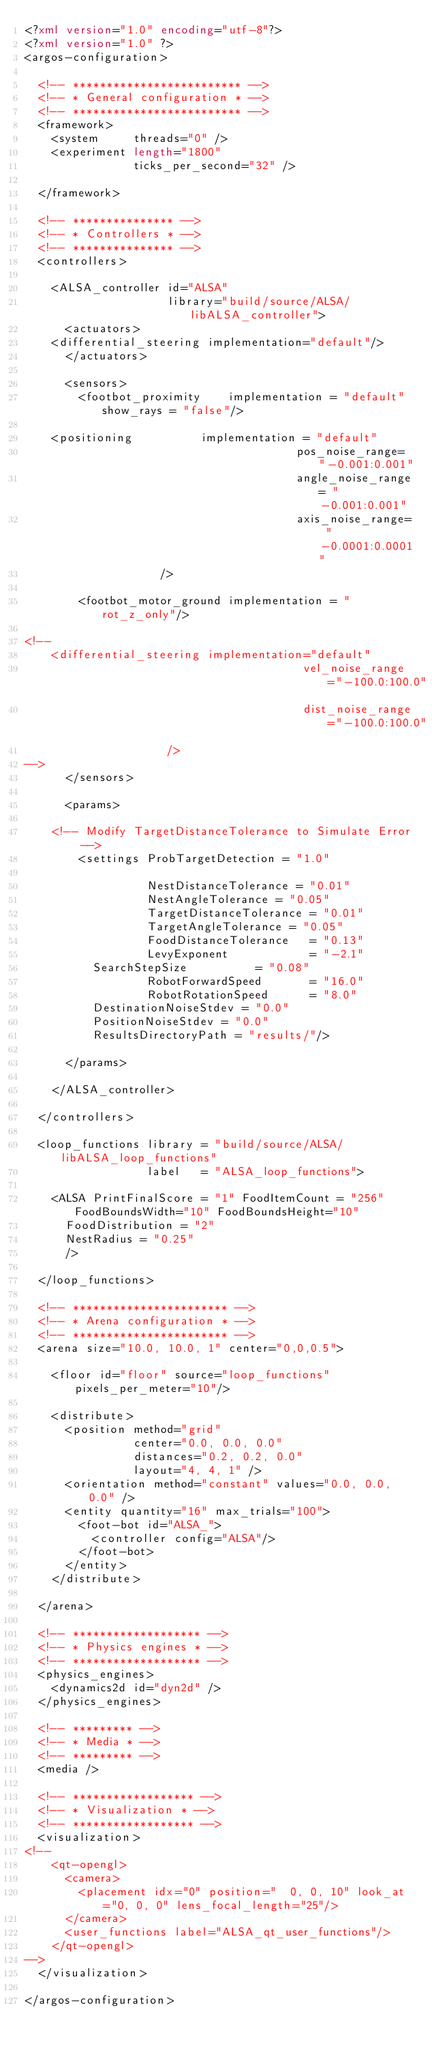Convert code to text. <code><loc_0><loc_0><loc_500><loc_500><_XML_><?xml version="1.0" encoding="utf-8"?>
<?xml version="1.0" ?>
<argos-configuration>

  <!-- ************************* -->
  <!-- * General configuration * -->
  <!-- ************************* -->
  <framework>
    <system     threads="0" />
    <experiment length="1800"
                ticks_per_second="32" />
                
  </framework>

  <!-- *************** -->
  <!-- * Controllers * -->
  <!-- *************** -->
  <controllers>

    <ALSA_controller id="ALSA"
                     library="build/source/ALSA/libALSA_controller">
      <actuators>
	<differential_steering implementation="default"/>
      </actuators>

      <sensors>
        <footbot_proximity    implementation = "default" show_rays = "false"/>
        
	<positioning          implementation = "default"
                                        pos_noise_range= "-0.001:0.001"
                                        angle_noise_range= "-0.001:0.001"
                                        axis_noise_range= "-0.0001:0.0001"
					/>	

        <footbot_motor_ground implementation = "rot_z_only"/>
	
<!--
	<differential_steering implementation="default"
                                         vel_noise_range="-100.0:100.0"
                                         dist_noise_range="-100.0:100.0" 
					 />
-->
      </sensors>

      <params>

	<!-- Modify TargetDistanceTolerance to Simulate Error -->
        <settings ProbTargetDetection = "1.0"   
                  
                  NestDistanceTolerance = "0.01"  
                  NestAngleTolerance = "0.05"  
                  TargetDistanceTolerance = "0.01"  
                  TargetAngleTolerance = "0.05"
                  FoodDistanceTolerance   = "0.13"
                  LevyExponent            = "-2.1"                   
		  SearchStepSize          = "0.08"
                  RobotForwardSpeed       = "16.0"
                  RobotRotationSpeed      = "8.0"
		  DestinationNoiseStdev = "0.0"
		  PositionNoiseStdev = "0.0"
		  ResultsDirectoryPath = "results/"/>
	          
      </params>

    </ALSA_controller>

  </controllers>

  <loop_functions library = "build/source/ALSA/libALSA_loop_functions"
                  label   = "ALSA_loop_functions">

    <ALSA PrintFinalScore = "1" FoodItemCount = "256" FoodBoundsWidth="10" FoodBoundsHeight="10"
	  FoodDistribution = "2"
	  NestRadius = "0.25"
	  />

  </loop_functions>
        
  <!-- *********************** -->
  <!-- * Arena configuration * -->
  <!-- *********************** -->
  <arena size="10.0, 10.0, 1" center="0,0,0.5">

    <floor id="floor" source="loop_functions" pixels_per_meter="10"/>

    <distribute>
      <position method="grid"
                center="0.0, 0.0, 0.0"
                distances="0.2, 0.2, 0.0"
                layout="4, 4, 1" />
      <orientation method="constant" values="0.0, 0.0, 0.0" />
      <entity quantity="16" max_trials="100">
        <foot-bot id="ALSA_">
          <controller config="ALSA"/>
        </foot-bot>
      </entity>
    </distribute>

  </arena>

  <!-- ******************* -->
  <!-- * Physics engines * -->
  <!-- ******************* -->
  <physics_engines>
    <dynamics2d id="dyn2d" />
  </physics_engines>

  <!-- ********* -->
  <!-- * Media * -->
  <!-- ********* -->
  <media />

  <!-- ****************** -->
  <!-- * Visualization * -->
  <!-- ****************** -->
  <visualization>
<!--
    <qt-opengl>
      <camera>
        <placement idx="0" position="  0, 0, 10" look_at="0, 0, 0" lens_focal_length="25"/>
      </camera>
      <user_functions label="ALSA_qt_user_functions"/>
    </qt-opengl>
-->
  </visualization>

</argos-configuration>
</code> 